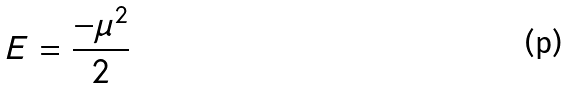Convert formula to latex. <formula><loc_0><loc_0><loc_500><loc_500>E = \frac { - \mu ^ { 2 } } { 2 }</formula> 